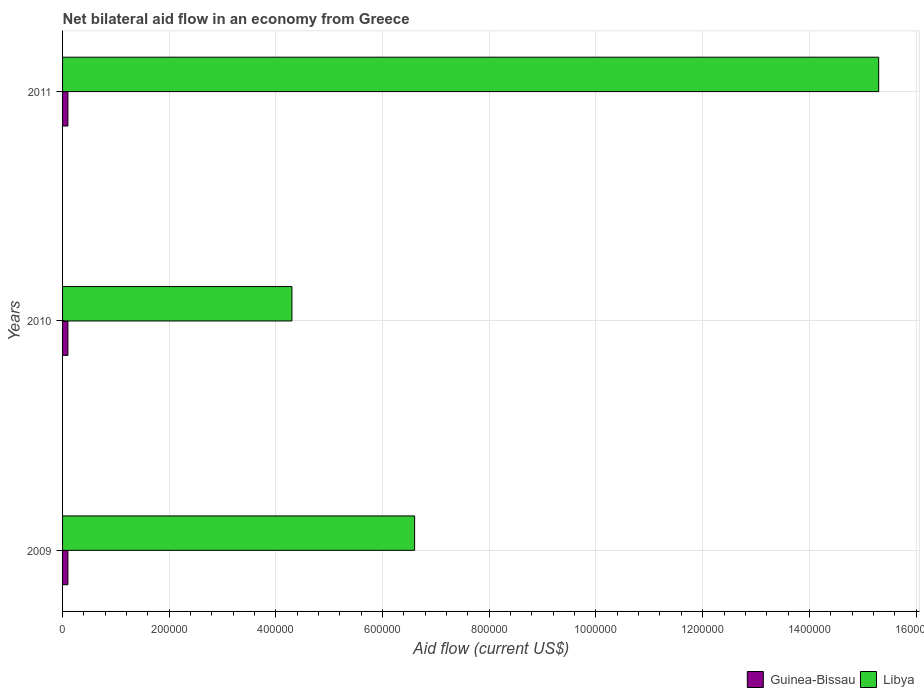How many groups of bars are there?
Provide a succinct answer. 3. Are the number of bars per tick equal to the number of legend labels?
Provide a short and direct response. Yes. Are the number of bars on each tick of the Y-axis equal?
Give a very brief answer. Yes. What is the net bilateral aid flow in Guinea-Bissau in 2011?
Your response must be concise. 10000. Across all years, what is the maximum net bilateral aid flow in Guinea-Bissau?
Offer a very short reply. 10000. What is the total net bilateral aid flow in Guinea-Bissau in the graph?
Provide a short and direct response. 3.00e+04. What is the difference between the net bilateral aid flow in Libya in 2009 and that in 2011?
Your answer should be very brief. -8.70e+05. What is the difference between the net bilateral aid flow in Guinea-Bissau in 2010 and the net bilateral aid flow in Libya in 2011?
Keep it short and to the point. -1.52e+06. In the year 2011, what is the difference between the net bilateral aid flow in Libya and net bilateral aid flow in Guinea-Bissau?
Give a very brief answer. 1.52e+06. Is the difference between the net bilateral aid flow in Libya in 2009 and 2010 greater than the difference between the net bilateral aid flow in Guinea-Bissau in 2009 and 2010?
Offer a terse response. Yes. What is the difference between the highest and the second highest net bilateral aid flow in Guinea-Bissau?
Provide a short and direct response. 0. What is the difference between the highest and the lowest net bilateral aid flow in Libya?
Your answer should be very brief. 1.10e+06. In how many years, is the net bilateral aid flow in Libya greater than the average net bilateral aid flow in Libya taken over all years?
Offer a terse response. 1. Is the sum of the net bilateral aid flow in Guinea-Bissau in 2009 and 2010 greater than the maximum net bilateral aid flow in Libya across all years?
Provide a succinct answer. No. What does the 1st bar from the top in 2009 represents?
Give a very brief answer. Libya. What does the 1st bar from the bottom in 2009 represents?
Offer a very short reply. Guinea-Bissau. How many bars are there?
Provide a succinct answer. 6. Are all the bars in the graph horizontal?
Give a very brief answer. Yes. Are the values on the major ticks of X-axis written in scientific E-notation?
Provide a short and direct response. No. Where does the legend appear in the graph?
Make the answer very short. Bottom right. How many legend labels are there?
Make the answer very short. 2. How are the legend labels stacked?
Offer a terse response. Horizontal. What is the title of the graph?
Your answer should be very brief. Net bilateral aid flow in an economy from Greece. What is the label or title of the Y-axis?
Provide a short and direct response. Years. What is the Aid flow (current US$) of Guinea-Bissau in 2009?
Ensure brevity in your answer.  10000. What is the Aid flow (current US$) in Libya in 2009?
Your answer should be compact. 6.60e+05. What is the Aid flow (current US$) in Libya in 2010?
Give a very brief answer. 4.30e+05. What is the Aid flow (current US$) of Guinea-Bissau in 2011?
Provide a short and direct response. 10000. What is the Aid flow (current US$) in Libya in 2011?
Ensure brevity in your answer.  1.53e+06. Across all years, what is the maximum Aid flow (current US$) in Guinea-Bissau?
Your answer should be compact. 10000. Across all years, what is the maximum Aid flow (current US$) of Libya?
Provide a short and direct response. 1.53e+06. Across all years, what is the minimum Aid flow (current US$) in Guinea-Bissau?
Offer a very short reply. 10000. Across all years, what is the minimum Aid flow (current US$) of Libya?
Offer a terse response. 4.30e+05. What is the total Aid flow (current US$) of Guinea-Bissau in the graph?
Provide a short and direct response. 3.00e+04. What is the total Aid flow (current US$) in Libya in the graph?
Make the answer very short. 2.62e+06. What is the difference between the Aid flow (current US$) of Libya in 2009 and that in 2010?
Provide a succinct answer. 2.30e+05. What is the difference between the Aid flow (current US$) of Guinea-Bissau in 2009 and that in 2011?
Your answer should be compact. 0. What is the difference between the Aid flow (current US$) of Libya in 2009 and that in 2011?
Provide a short and direct response. -8.70e+05. What is the difference between the Aid flow (current US$) of Guinea-Bissau in 2010 and that in 2011?
Your response must be concise. 0. What is the difference between the Aid flow (current US$) in Libya in 2010 and that in 2011?
Give a very brief answer. -1.10e+06. What is the difference between the Aid flow (current US$) in Guinea-Bissau in 2009 and the Aid flow (current US$) in Libya in 2010?
Provide a short and direct response. -4.20e+05. What is the difference between the Aid flow (current US$) of Guinea-Bissau in 2009 and the Aid flow (current US$) of Libya in 2011?
Provide a succinct answer. -1.52e+06. What is the difference between the Aid flow (current US$) in Guinea-Bissau in 2010 and the Aid flow (current US$) in Libya in 2011?
Offer a terse response. -1.52e+06. What is the average Aid flow (current US$) of Libya per year?
Provide a succinct answer. 8.73e+05. In the year 2009, what is the difference between the Aid flow (current US$) of Guinea-Bissau and Aid flow (current US$) of Libya?
Make the answer very short. -6.50e+05. In the year 2010, what is the difference between the Aid flow (current US$) in Guinea-Bissau and Aid flow (current US$) in Libya?
Offer a very short reply. -4.20e+05. In the year 2011, what is the difference between the Aid flow (current US$) of Guinea-Bissau and Aid flow (current US$) of Libya?
Your response must be concise. -1.52e+06. What is the ratio of the Aid flow (current US$) in Libya in 2009 to that in 2010?
Your response must be concise. 1.53. What is the ratio of the Aid flow (current US$) of Libya in 2009 to that in 2011?
Your answer should be compact. 0.43. What is the ratio of the Aid flow (current US$) in Guinea-Bissau in 2010 to that in 2011?
Ensure brevity in your answer.  1. What is the ratio of the Aid flow (current US$) of Libya in 2010 to that in 2011?
Provide a short and direct response. 0.28. What is the difference between the highest and the second highest Aid flow (current US$) of Guinea-Bissau?
Your answer should be compact. 0. What is the difference between the highest and the second highest Aid flow (current US$) in Libya?
Provide a succinct answer. 8.70e+05. What is the difference between the highest and the lowest Aid flow (current US$) of Libya?
Ensure brevity in your answer.  1.10e+06. 